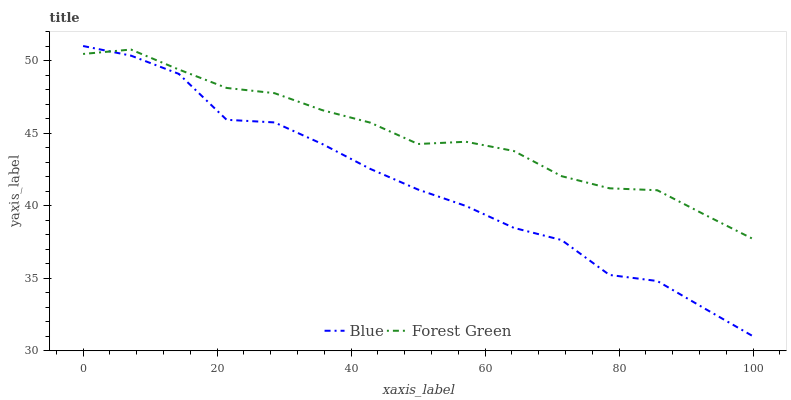Does Blue have the minimum area under the curve?
Answer yes or no. Yes. Does Forest Green have the maximum area under the curve?
Answer yes or no. Yes. Does Forest Green have the minimum area under the curve?
Answer yes or no. No. Is Forest Green the smoothest?
Answer yes or no. Yes. Is Blue the roughest?
Answer yes or no. Yes. Is Forest Green the roughest?
Answer yes or no. No. Does Forest Green have the lowest value?
Answer yes or no. No. Does Blue have the highest value?
Answer yes or no. Yes. Does Forest Green have the highest value?
Answer yes or no. No. Does Forest Green intersect Blue?
Answer yes or no. Yes. Is Forest Green less than Blue?
Answer yes or no. No. Is Forest Green greater than Blue?
Answer yes or no. No. 